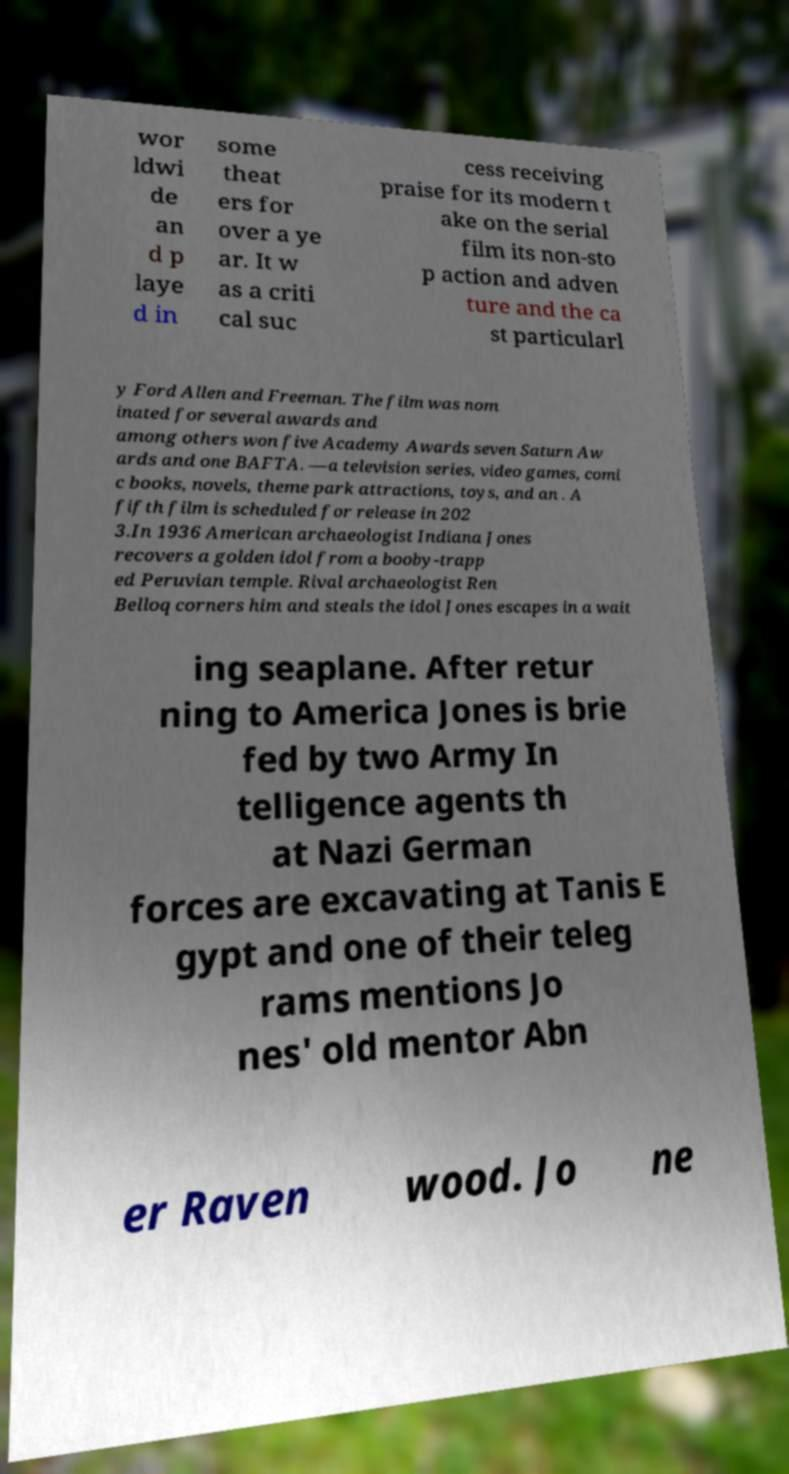Can you accurately transcribe the text from the provided image for me? wor ldwi de an d p laye d in some theat ers for over a ye ar. It w as a criti cal suc cess receiving praise for its modern t ake on the serial film its non-sto p action and adven ture and the ca st particularl y Ford Allen and Freeman. The film was nom inated for several awards and among others won five Academy Awards seven Saturn Aw ards and one BAFTA. —a television series, video games, comi c books, novels, theme park attractions, toys, and an . A fifth film is scheduled for release in 202 3.In 1936 American archaeologist Indiana Jones recovers a golden idol from a booby-trapp ed Peruvian temple. Rival archaeologist Ren Belloq corners him and steals the idol Jones escapes in a wait ing seaplane. After retur ning to America Jones is brie fed by two Army In telligence agents th at Nazi German forces are excavating at Tanis E gypt and one of their teleg rams mentions Jo nes' old mentor Abn er Raven wood. Jo ne 